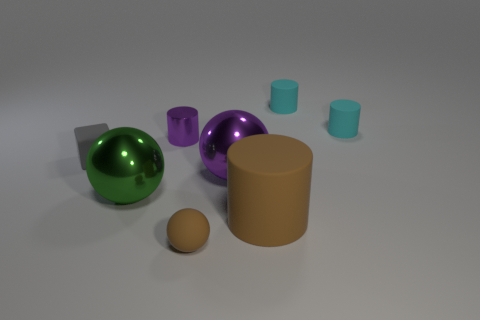How many things are either green rubber objects or small purple things that are on the left side of the big purple metallic sphere?
Give a very brief answer. 1. Does the tiny rubber sphere have the same color as the shiny cylinder behind the cube?
Your answer should be very brief. No. There is a rubber object that is both in front of the gray object and behind the tiny rubber ball; how big is it?
Ensure brevity in your answer.  Large. Are there any big spheres to the right of the tiny purple cylinder?
Your response must be concise. Yes. There is a brown matte thing left of the large cylinder; are there any tiny matte spheres that are behind it?
Provide a short and direct response. No. Are there the same number of tiny purple metal cylinders that are left of the cube and purple shiny objects that are right of the large brown cylinder?
Keep it short and to the point. Yes. The ball that is made of the same material as the big purple object is what color?
Offer a very short reply. Green. Are there any large cyan cubes made of the same material as the purple ball?
Offer a terse response. No. What number of objects are either large brown rubber spheres or green balls?
Your response must be concise. 1. Does the big purple object have the same material as the brown object that is behind the brown sphere?
Provide a succinct answer. No. 